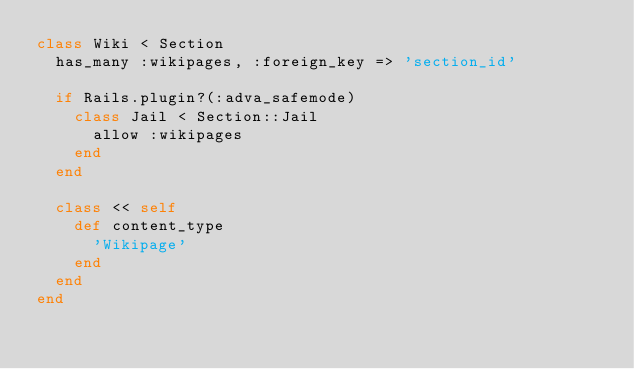Convert code to text. <code><loc_0><loc_0><loc_500><loc_500><_Ruby_>class Wiki < Section
  has_many :wikipages, :foreign_key => 'section_id'
    
  if Rails.plugin?(:adva_safemode)
    class Jail < Section::Jail
      allow :wikipages
    end
  end

  class << self
    def content_type
      'Wikipage'
    end
  end
end
</code> 